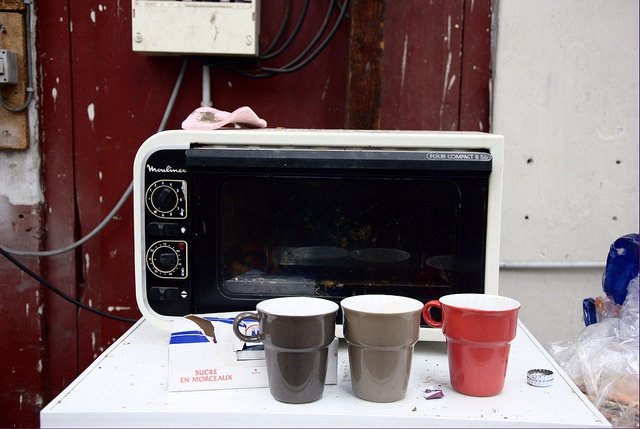Describe the objects in this image and their specific colors. I can see oven in maroon, black, white, gray, and darkgray tones, microwave in maroon, black, lightgray, gray, and darkgray tones, cup in maroon, gray, black, and white tones, cup in maroon, brown, white, and salmon tones, and cup in maroon, gray, and white tones in this image. 